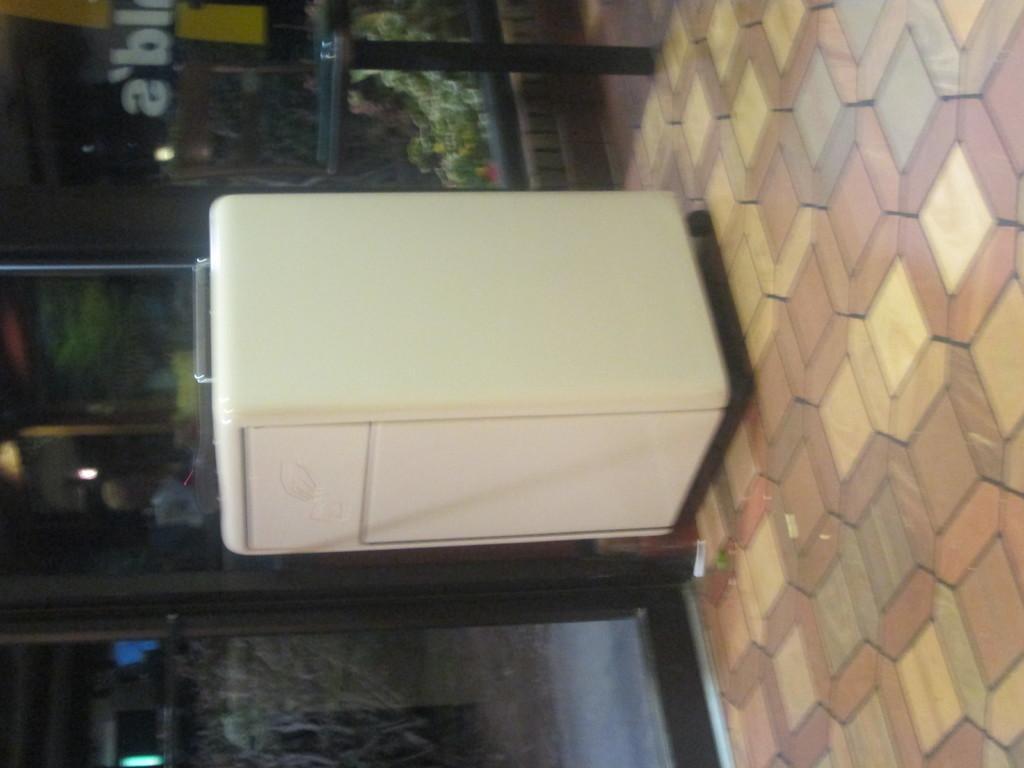In one or two sentences, can you explain what this image depicts? In this picture we can see white object and table on the floor. We can see poster on glass, through glass we can see plants. 